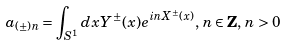Convert formula to latex. <formula><loc_0><loc_0><loc_500><loc_500>a _ { ( \pm ) n } = \int _ { S ^ { 1 } } d x Y ^ { \pm } ( x ) e ^ { i n X ^ { \pm } ( x ) } , \, n \in { \mathbf Z } , \, n > 0</formula> 